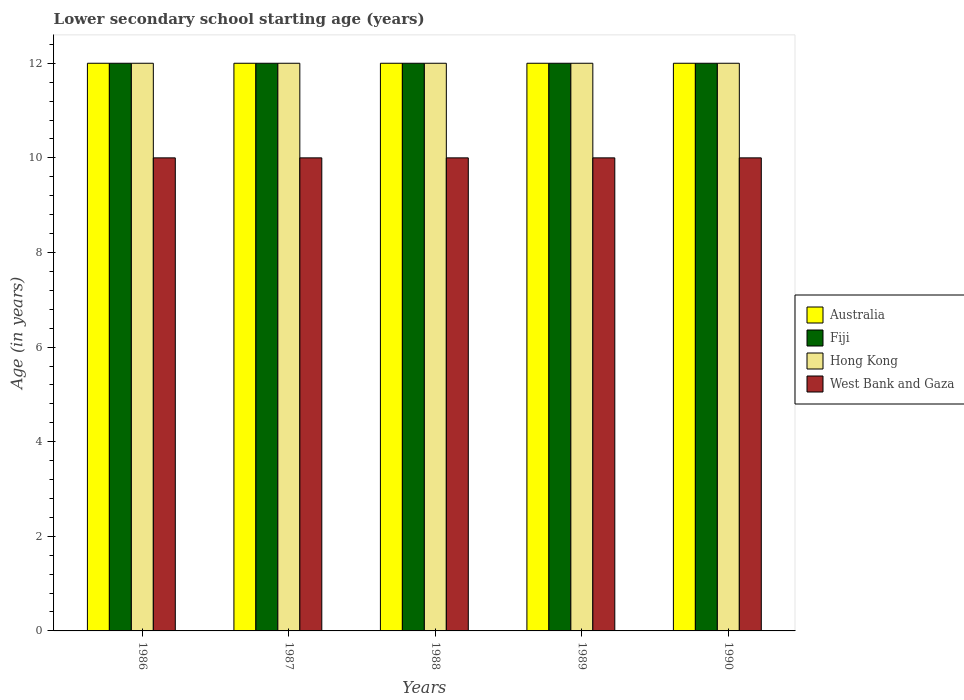Are the number of bars on each tick of the X-axis equal?
Your answer should be very brief. Yes. How many bars are there on the 2nd tick from the right?
Your answer should be compact. 4. In how many cases, is the number of bars for a given year not equal to the number of legend labels?
Ensure brevity in your answer.  0. What is the lower secondary school starting age of children in West Bank and Gaza in 1990?
Your response must be concise. 10. Across all years, what is the maximum lower secondary school starting age of children in Australia?
Offer a terse response. 12. Across all years, what is the minimum lower secondary school starting age of children in Hong Kong?
Ensure brevity in your answer.  12. In which year was the lower secondary school starting age of children in Fiji maximum?
Your answer should be compact. 1986. What is the total lower secondary school starting age of children in West Bank and Gaza in the graph?
Give a very brief answer. 50. What is the difference between the lower secondary school starting age of children in Fiji in 1989 and the lower secondary school starting age of children in Australia in 1990?
Offer a terse response. 0. What is the ratio of the lower secondary school starting age of children in West Bank and Gaza in 1986 to that in 1989?
Your response must be concise. 1. Is the lower secondary school starting age of children in Australia in 1986 less than that in 1990?
Ensure brevity in your answer.  No. Is the difference between the lower secondary school starting age of children in Australia in 1986 and 1988 greater than the difference between the lower secondary school starting age of children in Hong Kong in 1986 and 1988?
Offer a terse response. No. What is the difference between the highest and the lowest lower secondary school starting age of children in Hong Kong?
Offer a terse response. 0. Is it the case that in every year, the sum of the lower secondary school starting age of children in Australia and lower secondary school starting age of children in Fiji is greater than the sum of lower secondary school starting age of children in West Bank and Gaza and lower secondary school starting age of children in Hong Kong?
Your response must be concise. No. What does the 3rd bar from the left in 1990 represents?
Your response must be concise. Hong Kong. What does the 3rd bar from the right in 1988 represents?
Ensure brevity in your answer.  Fiji. What is the difference between two consecutive major ticks on the Y-axis?
Provide a succinct answer. 2. Are the values on the major ticks of Y-axis written in scientific E-notation?
Provide a short and direct response. No. Does the graph contain any zero values?
Provide a succinct answer. No. Does the graph contain grids?
Your response must be concise. No. Where does the legend appear in the graph?
Offer a very short reply. Center right. How are the legend labels stacked?
Provide a short and direct response. Vertical. What is the title of the graph?
Give a very brief answer. Lower secondary school starting age (years). What is the label or title of the X-axis?
Offer a very short reply. Years. What is the label or title of the Y-axis?
Your answer should be compact. Age (in years). What is the Age (in years) in Fiji in 1986?
Provide a succinct answer. 12. What is the Age (in years) of West Bank and Gaza in 1986?
Offer a terse response. 10. What is the Age (in years) in Fiji in 1987?
Your answer should be compact. 12. What is the Age (in years) of West Bank and Gaza in 1987?
Provide a succinct answer. 10. What is the Age (in years) of Hong Kong in 1988?
Offer a very short reply. 12. What is the Age (in years) of West Bank and Gaza in 1988?
Offer a very short reply. 10. What is the Age (in years) in Fiji in 1989?
Your response must be concise. 12. What is the Age (in years) in Hong Kong in 1989?
Your response must be concise. 12. What is the Age (in years) in West Bank and Gaza in 1989?
Offer a terse response. 10. What is the Age (in years) in Australia in 1990?
Your answer should be very brief. 12. What is the Age (in years) of Fiji in 1990?
Provide a succinct answer. 12. What is the Age (in years) in Hong Kong in 1990?
Offer a very short reply. 12. What is the Age (in years) in West Bank and Gaza in 1990?
Offer a very short reply. 10. Across all years, what is the maximum Age (in years) of Australia?
Provide a succinct answer. 12. Across all years, what is the maximum Age (in years) in Fiji?
Give a very brief answer. 12. Across all years, what is the minimum Age (in years) of Australia?
Offer a terse response. 12. Across all years, what is the minimum Age (in years) in Fiji?
Provide a succinct answer. 12. Across all years, what is the minimum Age (in years) in Hong Kong?
Keep it short and to the point. 12. Across all years, what is the minimum Age (in years) in West Bank and Gaza?
Your response must be concise. 10. What is the total Age (in years) in Fiji in the graph?
Provide a short and direct response. 60. What is the total Age (in years) of Hong Kong in the graph?
Offer a terse response. 60. What is the total Age (in years) in West Bank and Gaza in the graph?
Your answer should be compact. 50. What is the difference between the Age (in years) of Fiji in 1986 and that in 1987?
Your answer should be very brief. 0. What is the difference between the Age (in years) of Fiji in 1986 and that in 1988?
Offer a terse response. 0. What is the difference between the Age (in years) in Hong Kong in 1986 and that in 1988?
Ensure brevity in your answer.  0. What is the difference between the Age (in years) of Australia in 1986 and that in 1989?
Offer a very short reply. 0. What is the difference between the Age (in years) in Fiji in 1986 and that in 1989?
Keep it short and to the point. 0. What is the difference between the Age (in years) of Australia in 1986 and that in 1990?
Give a very brief answer. 0. What is the difference between the Age (in years) of West Bank and Gaza in 1986 and that in 1990?
Make the answer very short. 0. What is the difference between the Age (in years) of Australia in 1987 and that in 1988?
Your answer should be compact. 0. What is the difference between the Age (in years) in Hong Kong in 1987 and that in 1988?
Ensure brevity in your answer.  0. What is the difference between the Age (in years) in Fiji in 1987 and that in 1989?
Your answer should be compact. 0. What is the difference between the Age (in years) of Australia in 1987 and that in 1990?
Your response must be concise. 0. What is the difference between the Age (in years) of Fiji in 1987 and that in 1990?
Your response must be concise. 0. What is the difference between the Age (in years) in Hong Kong in 1987 and that in 1990?
Make the answer very short. 0. What is the difference between the Age (in years) of West Bank and Gaza in 1987 and that in 1990?
Ensure brevity in your answer.  0. What is the difference between the Age (in years) in Australia in 1988 and that in 1989?
Offer a very short reply. 0. What is the difference between the Age (in years) in Fiji in 1988 and that in 1989?
Provide a short and direct response. 0. What is the difference between the Age (in years) of West Bank and Gaza in 1988 and that in 1989?
Ensure brevity in your answer.  0. What is the difference between the Age (in years) in Australia in 1988 and that in 1990?
Offer a terse response. 0. What is the difference between the Age (in years) in Fiji in 1988 and that in 1990?
Provide a succinct answer. 0. What is the difference between the Age (in years) of West Bank and Gaza in 1988 and that in 1990?
Give a very brief answer. 0. What is the difference between the Age (in years) of Fiji in 1989 and that in 1990?
Provide a short and direct response. 0. What is the difference between the Age (in years) of Hong Kong in 1989 and that in 1990?
Provide a short and direct response. 0. What is the difference between the Age (in years) of Australia in 1986 and the Age (in years) of Fiji in 1987?
Make the answer very short. 0. What is the difference between the Age (in years) in Australia in 1986 and the Age (in years) in Hong Kong in 1987?
Make the answer very short. 0. What is the difference between the Age (in years) in Fiji in 1986 and the Age (in years) in West Bank and Gaza in 1987?
Your answer should be compact. 2. What is the difference between the Age (in years) of Fiji in 1986 and the Age (in years) of Hong Kong in 1988?
Provide a succinct answer. 0. What is the difference between the Age (in years) of Fiji in 1986 and the Age (in years) of West Bank and Gaza in 1988?
Provide a short and direct response. 2. What is the difference between the Age (in years) in Hong Kong in 1986 and the Age (in years) in West Bank and Gaza in 1988?
Give a very brief answer. 2. What is the difference between the Age (in years) of Australia in 1986 and the Age (in years) of Fiji in 1989?
Your answer should be very brief. 0. What is the difference between the Age (in years) in Fiji in 1986 and the Age (in years) in Hong Kong in 1989?
Offer a terse response. 0. What is the difference between the Age (in years) of Australia in 1986 and the Age (in years) of Hong Kong in 1990?
Your answer should be very brief. 0. What is the difference between the Age (in years) of Australia in 1987 and the Age (in years) of Hong Kong in 1988?
Your answer should be very brief. 0. What is the difference between the Age (in years) in Fiji in 1987 and the Age (in years) in Hong Kong in 1988?
Offer a very short reply. 0. What is the difference between the Age (in years) in Hong Kong in 1987 and the Age (in years) in West Bank and Gaza in 1988?
Offer a very short reply. 2. What is the difference between the Age (in years) of Australia in 1987 and the Age (in years) of Fiji in 1989?
Offer a very short reply. 0. What is the difference between the Age (in years) of Australia in 1987 and the Age (in years) of Hong Kong in 1989?
Offer a very short reply. 0. What is the difference between the Age (in years) in Australia in 1987 and the Age (in years) in West Bank and Gaza in 1989?
Give a very brief answer. 2. What is the difference between the Age (in years) in Hong Kong in 1987 and the Age (in years) in West Bank and Gaza in 1989?
Provide a short and direct response. 2. What is the difference between the Age (in years) in Australia in 1987 and the Age (in years) in Fiji in 1990?
Provide a short and direct response. 0. What is the difference between the Age (in years) in Fiji in 1987 and the Age (in years) in Hong Kong in 1990?
Your answer should be very brief. 0. What is the difference between the Age (in years) in Fiji in 1987 and the Age (in years) in West Bank and Gaza in 1990?
Offer a terse response. 2. What is the difference between the Age (in years) in Hong Kong in 1987 and the Age (in years) in West Bank and Gaza in 1990?
Offer a very short reply. 2. What is the difference between the Age (in years) in Australia in 1988 and the Age (in years) in Hong Kong in 1989?
Give a very brief answer. 0. What is the difference between the Age (in years) of Australia in 1988 and the Age (in years) of West Bank and Gaza in 1989?
Keep it short and to the point. 2. What is the difference between the Age (in years) in Fiji in 1988 and the Age (in years) in West Bank and Gaza in 1989?
Your answer should be very brief. 2. What is the difference between the Age (in years) of Australia in 1988 and the Age (in years) of Fiji in 1990?
Your answer should be compact. 0. What is the difference between the Age (in years) of Australia in 1988 and the Age (in years) of Hong Kong in 1990?
Offer a terse response. 0. What is the difference between the Age (in years) of Fiji in 1988 and the Age (in years) of West Bank and Gaza in 1990?
Make the answer very short. 2. What is the difference between the Age (in years) of Australia in 1989 and the Age (in years) of Hong Kong in 1990?
Make the answer very short. 0. What is the difference between the Age (in years) of Fiji in 1989 and the Age (in years) of West Bank and Gaza in 1990?
Provide a succinct answer. 2. What is the difference between the Age (in years) in Hong Kong in 1989 and the Age (in years) in West Bank and Gaza in 1990?
Give a very brief answer. 2. What is the average Age (in years) in Australia per year?
Offer a terse response. 12. What is the average Age (in years) of Fiji per year?
Offer a terse response. 12. What is the average Age (in years) in West Bank and Gaza per year?
Your answer should be compact. 10. In the year 1986, what is the difference between the Age (in years) in Australia and Age (in years) in Fiji?
Your answer should be compact. 0. In the year 1986, what is the difference between the Age (in years) in Australia and Age (in years) in Hong Kong?
Your answer should be very brief. 0. In the year 1987, what is the difference between the Age (in years) of Australia and Age (in years) of Fiji?
Offer a terse response. 0. In the year 1987, what is the difference between the Age (in years) in Hong Kong and Age (in years) in West Bank and Gaza?
Your answer should be compact. 2. In the year 1988, what is the difference between the Age (in years) in Australia and Age (in years) in Hong Kong?
Provide a short and direct response. 0. In the year 1988, what is the difference between the Age (in years) of Australia and Age (in years) of West Bank and Gaza?
Make the answer very short. 2. In the year 1988, what is the difference between the Age (in years) of Fiji and Age (in years) of Hong Kong?
Keep it short and to the point. 0. In the year 1988, what is the difference between the Age (in years) of Fiji and Age (in years) of West Bank and Gaza?
Your answer should be very brief. 2. In the year 1989, what is the difference between the Age (in years) of Australia and Age (in years) of Hong Kong?
Your answer should be very brief. 0. In the year 1989, what is the difference between the Age (in years) of Australia and Age (in years) of West Bank and Gaza?
Your answer should be compact. 2. In the year 1989, what is the difference between the Age (in years) in Fiji and Age (in years) in Hong Kong?
Provide a succinct answer. 0. In the year 1989, what is the difference between the Age (in years) of Hong Kong and Age (in years) of West Bank and Gaza?
Keep it short and to the point. 2. In the year 1990, what is the difference between the Age (in years) in Australia and Age (in years) in Hong Kong?
Your response must be concise. 0. In the year 1990, what is the difference between the Age (in years) of Fiji and Age (in years) of West Bank and Gaza?
Provide a succinct answer. 2. In the year 1990, what is the difference between the Age (in years) of Hong Kong and Age (in years) of West Bank and Gaza?
Ensure brevity in your answer.  2. What is the ratio of the Age (in years) in Australia in 1986 to that in 1987?
Provide a succinct answer. 1. What is the ratio of the Age (in years) in Fiji in 1986 to that in 1987?
Your answer should be compact. 1. What is the ratio of the Age (in years) of Hong Kong in 1986 to that in 1987?
Offer a very short reply. 1. What is the ratio of the Age (in years) in Australia in 1986 to that in 1988?
Offer a terse response. 1. What is the ratio of the Age (in years) in Fiji in 1986 to that in 1988?
Provide a succinct answer. 1. What is the ratio of the Age (in years) of Hong Kong in 1986 to that in 1988?
Keep it short and to the point. 1. What is the ratio of the Age (in years) of Fiji in 1986 to that in 1989?
Give a very brief answer. 1. What is the ratio of the Age (in years) in West Bank and Gaza in 1986 to that in 1989?
Provide a short and direct response. 1. What is the ratio of the Age (in years) in Australia in 1986 to that in 1990?
Ensure brevity in your answer.  1. What is the ratio of the Age (in years) in Australia in 1987 to that in 1988?
Your answer should be compact. 1. What is the ratio of the Age (in years) of Fiji in 1987 to that in 1988?
Your answer should be very brief. 1. What is the ratio of the Age (in years) in Hong Kong in 1987 to that in 1989?
Give a very brief answer. 1. What is the ratio of the Age (in years) in Australia in 1987 to that in 1990?
Keep it short and to the point. 1. What is the ratio of the Age (in years) in Hong Kong in 1987 to that in 1990?
Provide a short and direct response. 1. What is the ratio of the Age (in years) in West Bank and Gaza in 1987 to that in 1990?
Give a very brief answer. 1. What is the ratio of the Age (in years) in Hong Kong in 1988 to that in 1989?
Keep it short and to the point. 1. What is the ratio of the Age (in years) in Fiji in 1989 to that in 1990?
Provide a short and direct response. 1. What is the ratio of the Age (in years) of Hong Kong in 1989 to that in 1990?
Give a very brief answer. 1. What is the ratio of the Age (in years) in West Bank and Gaza in 1989 to that in 1990?
Ensure brevity in your answer.  1. What is the difference between the highest and the second highest Age (in years) in Hong Kong?
Ensure brevity in your answer.  0. What is the difference between the highest and the second highest Age (in years) in West Bank and Gaza?
Offer a very short reply. 0. What is the difference between the highest and the lowest Age (in years) of Hong Kong?
Offer a terse response. 0. What is the difference between the highest and the lowest Age (in years) in West Bank and Gaza?
Give a very brief answer. 0. 